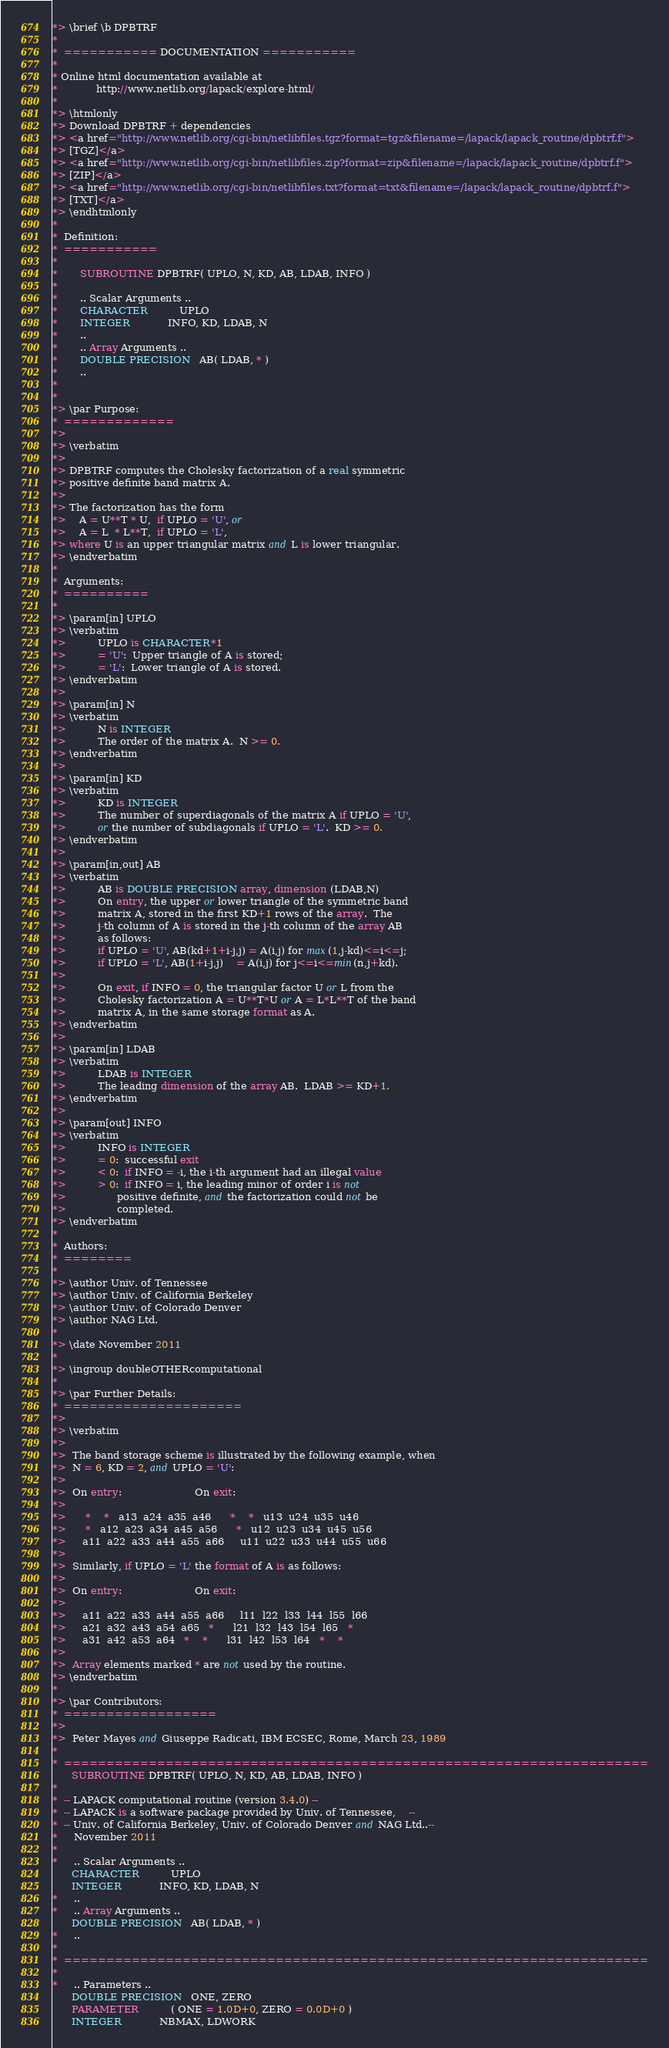Convert code to text. <code><loc_0><loc_0><loc_500><loc_500><_FORTRAN_>*> \brief \b DPBTRF
*
*  =========== DOCUMENTATION ===========
*
* Online html documentation available at 
*            http://www.netlib.org/lapack/explore-html/ 
*
*> \htmlonly
*> Download DPBTRF + dependencies 
*> <a href="http://www.netlib.org/cgi-bin/netlibfiles.tgz?format=tgz&filename=/lapack/lapack_routine/dpbtrf.f"> 
*> [TGZ]</a> 
*> <a href="http://www.netlib.org/cgi-bin/netlibfiles.zip?format=zip&filename=/lapack/lapack_routine/dpbtrf.f"> 
*> [ZIP]</a> 
*> <a href="http://www.netlib.org/cgi-bin/netlibfiles.txt?format=txt&filename=/lapack/lapack_routine/dpbtrf.f"> 
*> [TXT]</a>
*> \endhtmlonly 
*
*  Definition:
*  ===========
*
*       SUBROUTINE DPBTRF( UPLO, N, KD, AB, LDAB, INFO )
* 
*       .. Scalar Arguments ..
*       CHARACTER          UPLO
*       INTEGER            INFO, KD, LDAB, N
*       ..
*       .. Array Arguments ..
*       DOUBLE PRECISION   AB( LDAB, * )
*       ..
*  
*
*> \par Purpose:
*  =============
*>
*> \verbatim
*>
*> DPBTRF computes the Cholesky factorization of a real symmetric
*> positive definite band matrix A.
*>
*> The factorization has the form
*>    A = U**T * U,  if UPLO = 'U', or
*>    A = L  * L**T,  if UPLO = 'L',
*> where U is an upper triangular matrix and L is lower triangular.
*> \endverbatim
*
*  Arguments:
*  ==========
*
*> \param[in] UPLO
*> \verbatim
*>          UPLO is CHARACTER*1
*>          = 'U':  Upper triangle of A is stored;
*>          = 'L':  Lower triangle of A is stored.
*> \endverbatim
*>
*> \param[in] N
*> \verbatim
*>          N is INTEGER
*>          The order of the matrix A.  N >= 0.
*> \endverbatim
*>
*> \param[in] KD
*> \verbatim
*>          KD is INTEGER
*>          The number of superdiagonals of the matrix A if UPLO = 'U',
*>          or the number of subdiagonals if UPLO = 'L'.  KD >= 0.
*> \endverbatim
*>
*> \param[in,out] AB
*> \verbatim
*>          AB is DOUBLE PRECISION array, dimension (LDAB,N)
*>          On entry, the upper or lower triangle of the symmetric band
*>          matrix A, stored in the first KD+1 rows of the array.  The
*>          j-th column of A is stored in the j-th column of the array AB
*>          as follows:
*>          if UPLO = 'U', AB(kd+1+i-j,j) = A(i,j) for max(1,j-kd)<=i<=j;
*>          if UPLO = 'L', AB(1+i-j,j)    = A(i,j) for j<=i<=min(n,j+kd).
*>
*>          On exit, if INFO = 0, the triangular factor U or L from the
*>          Cholesky factorization A = U**T*U or A = L*L**T of the band
*>          matrix A, in the same storage format as A.
*> \endverbatim
*>
*> \param[in] LDAB
*> \verbatim
*>          LDAB is INTEGER
*>          The leading dimension of the array AB.  LDAB >= KD+1.
*> \endverbatim
*>
*> \param[out] INFO
*> \verbatim
*>          INFO is INTEGER
*>          = 0:  successful exit
*>          < 0:  if INFO = -i, the i-th argument had an illegal value
*>          > 0:  if INFO = i, the leading minor of order i is not
*>                positive definite, and the factorization could not be
*>                completed.
*> \endverbatim
*
*  Authors:
*  ========
*
*> \author Univ. of Tennessee 
*> \author Univ. of California Berkeley 
*> \author Univ. of Colorado Denver 
*> \author NAG Ltd. 
*
*> \date November 2011
*
*> \ingroup doubleOTHERcomputational
*
*> \par Further Details:
*  =====================
*>
*> \verbatim
*>
*>  The band storage scheme is illustrated by the following example, when
*>  N = 6, KD = 2, and UPLO = 'U':
*>
*>  On entry:                       On exit:
*>
*>      *    *   a13  a24  a35  a46      *    *   u13  u24  u35  u46
*>      *   a12  a23  a34  a45  a56      *   u12  u23  u34  u45  u56
*>     a11  a22  a33  a44  a55  a66     u11  u22  u33  u44  u55  u66
*>
*>  Similarly, if UPLO = 'L' the format of A is as follows:
*>
*>  On entry:                       On exit:
*>
*>     a11  a22  a33  a44  a55  a66     l11  l22  l33  l44  l55  l66
*>     a21  a32  a43  a54  a65   *      l21  l32  l43  l54  l65   *
*>     a31  a42  a53  a64   *    *      l31  l42  l53  l64   *    *
*>
*>  Array elements marked * are not used by the routine.
*> \endverbatim
*
*> \par Contributors:
*  ==================
*>
*>  Peter Mayes and Giuseppe Radicati, IBM ECSEC, Rome, March 23, 1989
*
*  =====================================================================
      SUBROUTINE DPBTRF( UPLO, N, KD, AB, LDAB, INFO )
*
*  -- LAPACK computational routine (version 3.4.0) --
*  -- LAPACK is a software package provided by Univ. of Tennessee,    --
*  -- Univ. of California Berkeley, Univ. of Colorado Denver and NAG Ltd..--
*     November 2011
*
*     .. Scalar Arguments ..
      CHARACTER          UPLO
      INTEGER            INFO, KD, LDAB, N
*     ..
*     .. Array Arguments ..
      DOUBLE PRECISION   AB( LDAB, * )
*     ..
*
*  =====================================================================
*
*     .. Parameters ..
      DOUBLE PRECISION   ONE, ZERO
      PARAMETER          ( ONE = 1.0D+0, ZERO = 0.0D+0 )
      INTEGER            NBMAX, LDWORK</code> 